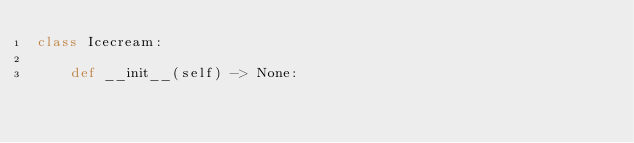Convert code to text. <code><loc_0><loc_0><loc_500><loc_500><_Python_>class Icecream:

    def __init__(self) -> None:
        </code> 